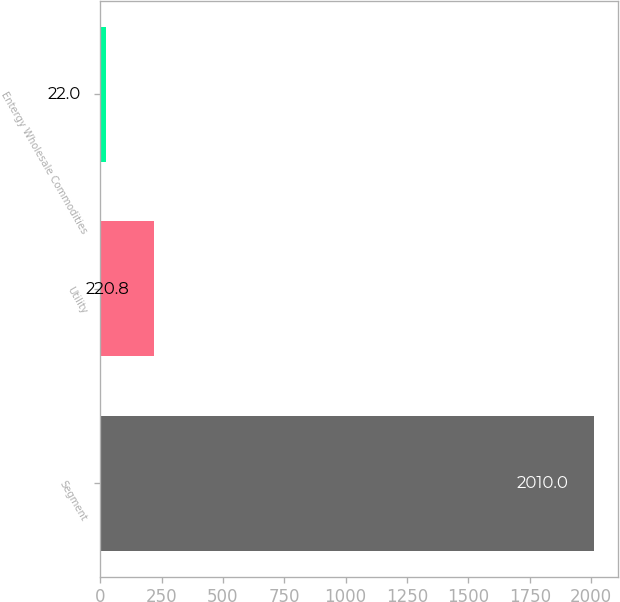Convert chart to OTSL. <chart><loc_0><loc_0><loc_500><loc_500><bar_chart><fcel>Segment<fcel>Utility<fcel>Entergy Wholesale Commodities<nl><fcel>2010<fcel>220.8<fcel>22<nl></chart> 